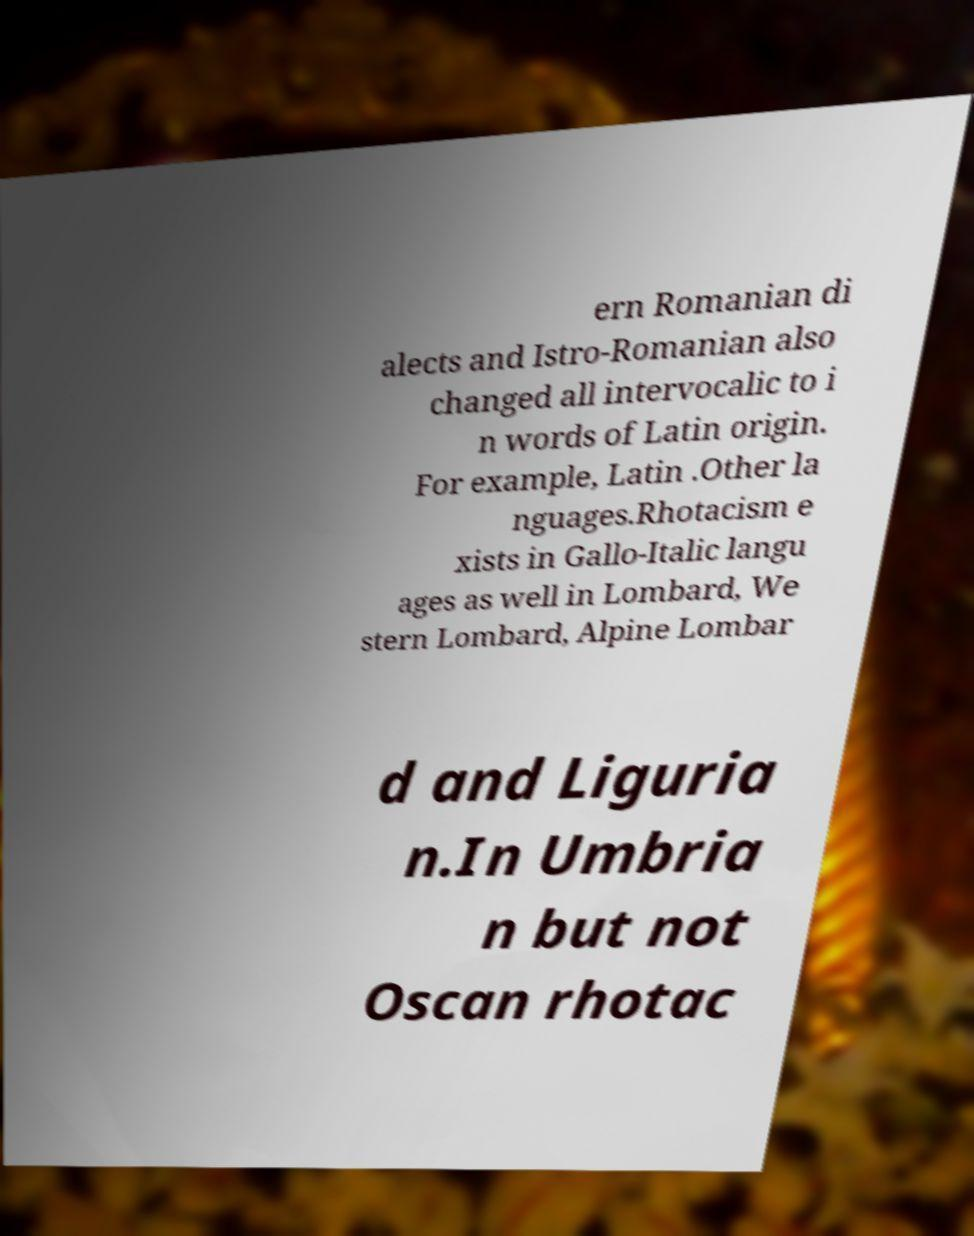Could you assist in decoding the text presented in this image and type it out clearly? ern Romanian di alects and Istro-Romanian also changed all intervocalic to i n words of Latin origin. For example, Latin .Other la nguages.Rhotacism e xists in Gallo-Italic langu ages as well in Lombard, We stern Lombard, Alpine Lombar d and Liguria n.In Umbria n but not Oscan rhotac 